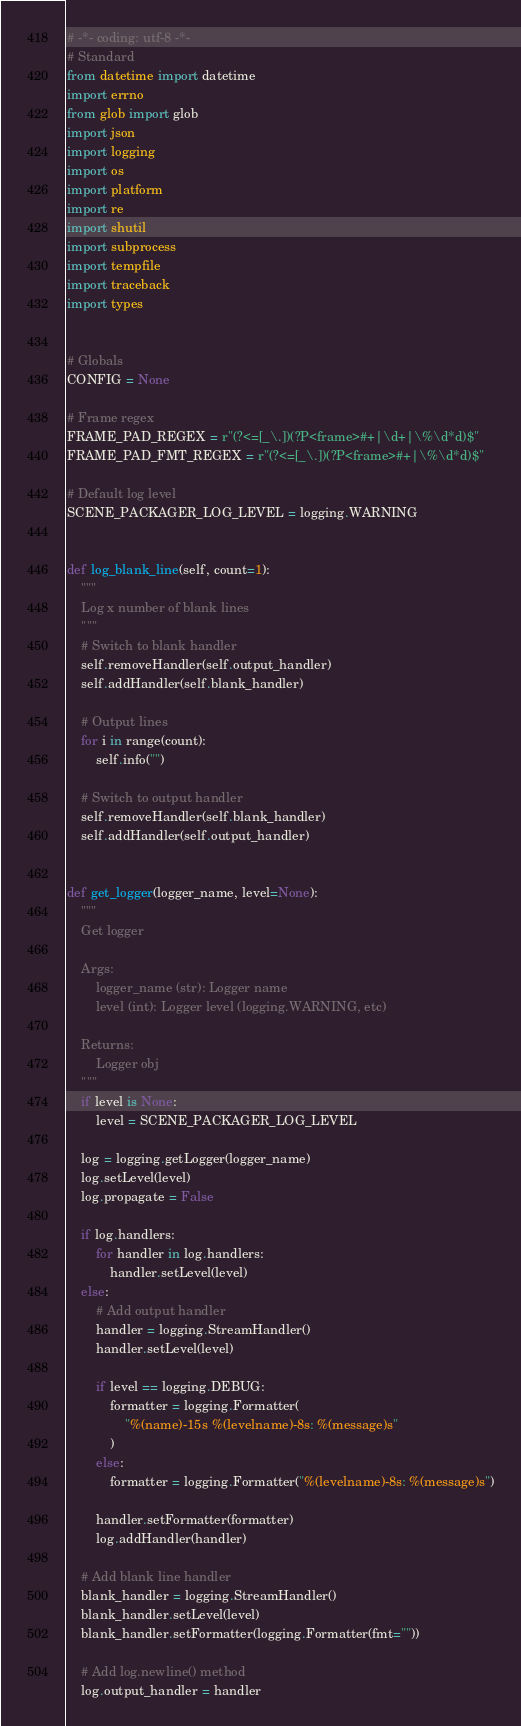<code> <loc_0><loc_0><loc_500><loc_500><_Python_># -*- coding: utf-8 -*-
# Standard
from datetime import datetime
import errno
from glob import glob
import json
import logging
import os
import platform
import re
import shutil
import subprocess
import tempfile
import traceback
import types


# Globals
CONFIG = None

# Frame regex
FRAME_PAD_REGEX = r"(?<=[_\.])(?P<frame>#+|\d+|\%\d*d)$"
FRAME_PAD_FMT_REGEX = r"(?<=[_\.])(?P<frame>#+|\%\d*d)$"

# Default log level
SCENE_PACKAGER_LOG_LEVEL = logging.WARNING


def log_blank_line(self, count=1):
    """
    Log x number of blank lines
    """
    # Switch to blank handler
    self.removeHandler(self.output_handler)
    self.addHandler(self.blank_handler)

    # Output lines
    for i in range(count):
        self.info("")

    # Switch to output handler
    self.removeHandler(self.blank_handler)
    self.addHandler(self.output_handler)


def get_logger(logger_name, level=None):
    """
    Get logger

    Args:
        logger_name (str): Logger name
        level (int): Logger level (logging.WARNING, etc)

    Returns:
        Logger obj
    """
    if level is None:
        level = SCENE_PACKAGER_LOG_LEVEL

    log = logging.getLogger(logger_name)
    log.setLevel(level)
    log.propagate = False

    if log.handlers:
        for handler in log.handlers:
            handler.setLevel(level)
    else:
        # Add output handler
        handler = logging.StreamHandler()
        handler.setLevel(level)

        if level == logging.DEBUG:
            formatter = logging.Formatter(
                "%(name)-15s %(levelname)-8s: %(message)s"
            )
        else:
            formatter = logging.Formatter("%(levelname)-8s: %(message)s")

        handler.setFormatter(formatter)
        log.addHandler(handler)

    # Add blank line handler
    blank_handler = logging.StreamHandler()
    blank_handler.setLevel(level)
    blank_handler.setFormatter(logging.Formatter(fmt=""))

    # Add log.newline() method
    log.output_handler = handler</code> 